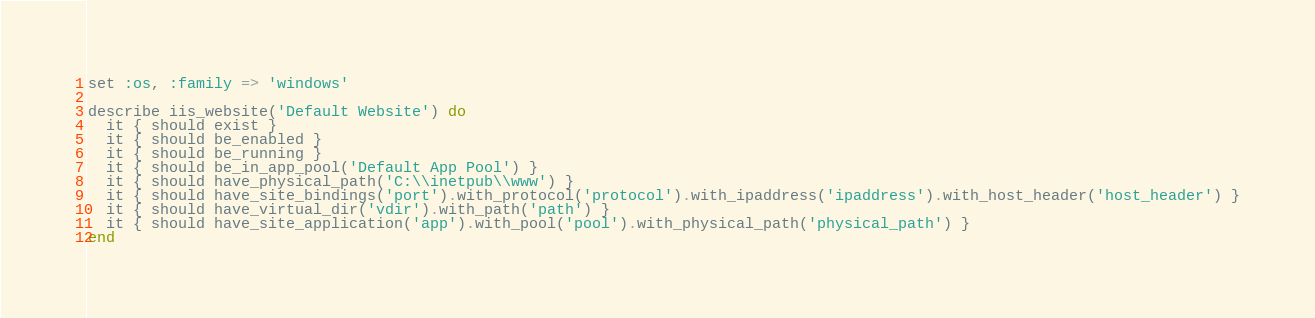<code> <loc_0><loc_0><loc_500><loc_500><_Ruby_>
set :os, :family => 'windows'

describe iis_website('Default Website') do
  it { should exist }
  it { should be_enabled }
  it { should be_running }
  it { should be_in_app_pool('Default App Pool') }
  it { should have_physical_path('C:\\inetpub\\www') } 
  it { should have_site_bindings('port').with_protocol('protocol').with_ipaddress('ipaddress').with_host_header('host_header') }
  it { should have_virtual_dir('vdir').with_path('path') }
  it { should have_site_application('app').with_pool('pool').with_physical_path('physical_path') }
end
</code> 